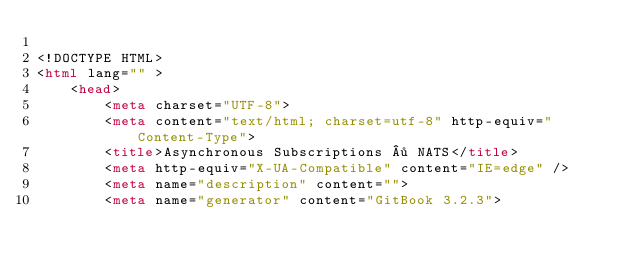Convert code to text. <code><loc_0><loc_0><loc_500><loc_500><_HTML_>
<!DOCTYPE HTML>
<html lang="" >
    <head>
        <meta charset="UTF-8">
        <meta content="text/html; charset=utf-8" http-equiv="Content-Type">
        <title>Asynchronous Subscriptions · NATS</title>
        <meta http-equiv="X-UA-Compatible" content="IE=edge" />
        <meta name="description" content="">
        <meta name="generator" content="GitBook 3.2.3"></code> 